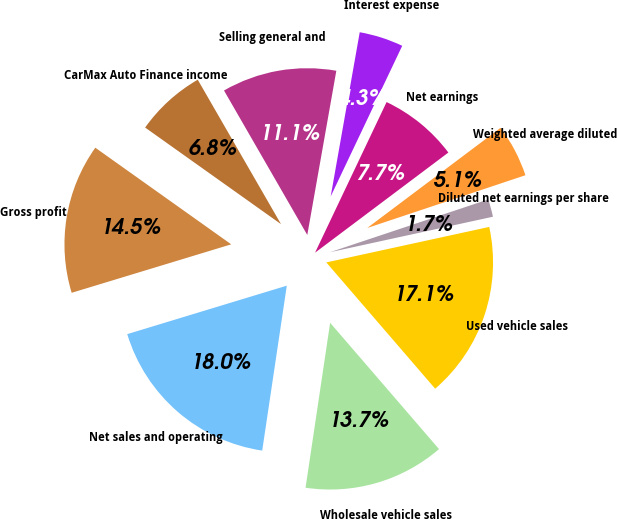<chart> <loc_0><loc_0><loc_500><loc_500><pie_chart><fcel>Used vehicle sales<fcel>Wholesale vehicle sales<fcel>Net sales and operating<fcel>Gross profit<fcel>CarMax Auto Finance income<fcel>Selling general and<fcel>Interest expense<fcel>Net earnings<fcel>Weighted average diluted<fcel>Diluted net earnings per share<nl><fcel>17.09%<fcel>13.68%<fcel>17.95%<fcel>14.53%<fcel>6.84%<fcel>11.11%<fcel>4.27%<fcel>7.69%<fcel>5.13%<fcel>1.71%<nl></chart> 